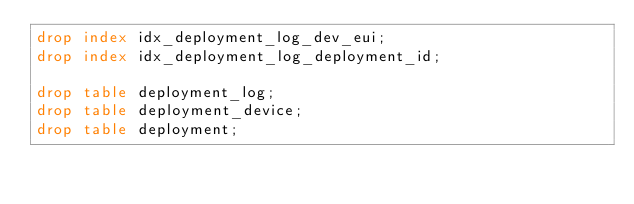<code> <loc_0><loc_0><loc_500><loc_500><_SQL_>drop index idx_deployment_log_dev_eui;
drop index idx_deployment_log_deployment_id;

drop table deployment_log;
drop table deployment_device;
drop table deployment;
</code> 